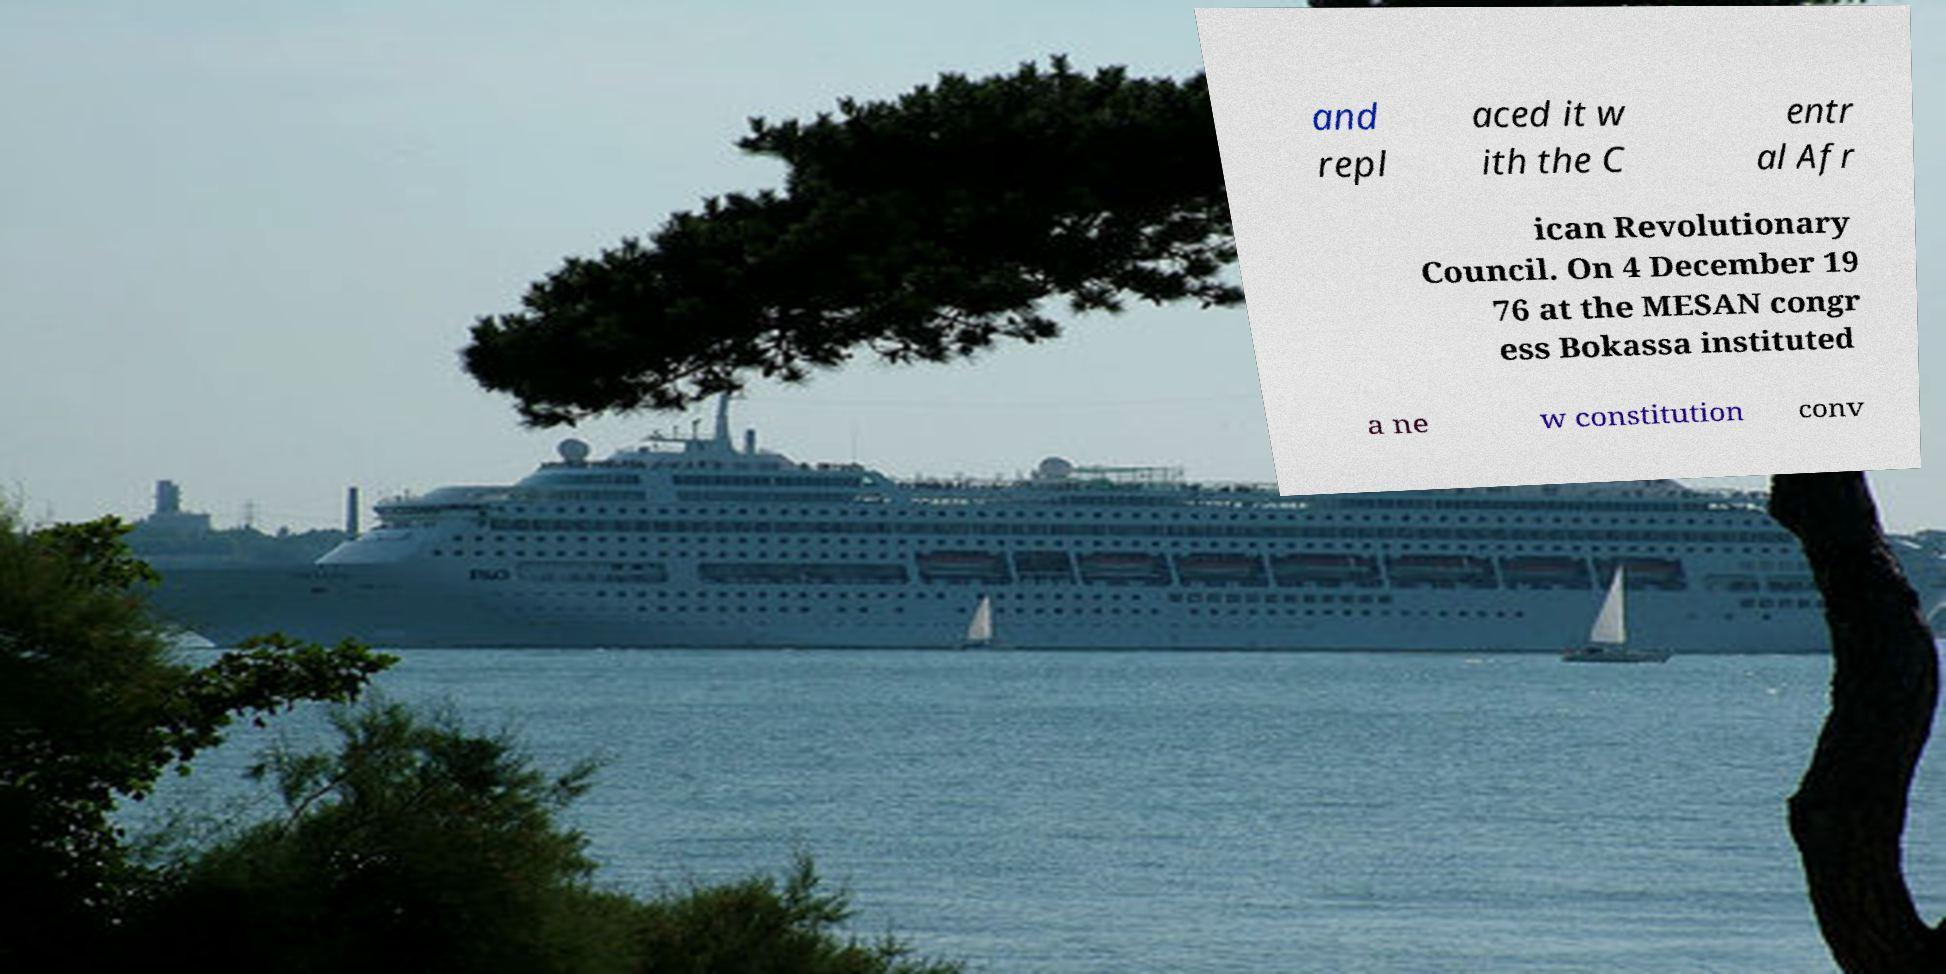Could you extract and type out the text from this image? and repl aced it w ith the C entr al Afr ican Revolutionary Council. On 4 December 19 76 at the MESAN congr ess Bokassa instituted a ne w constitution conv 